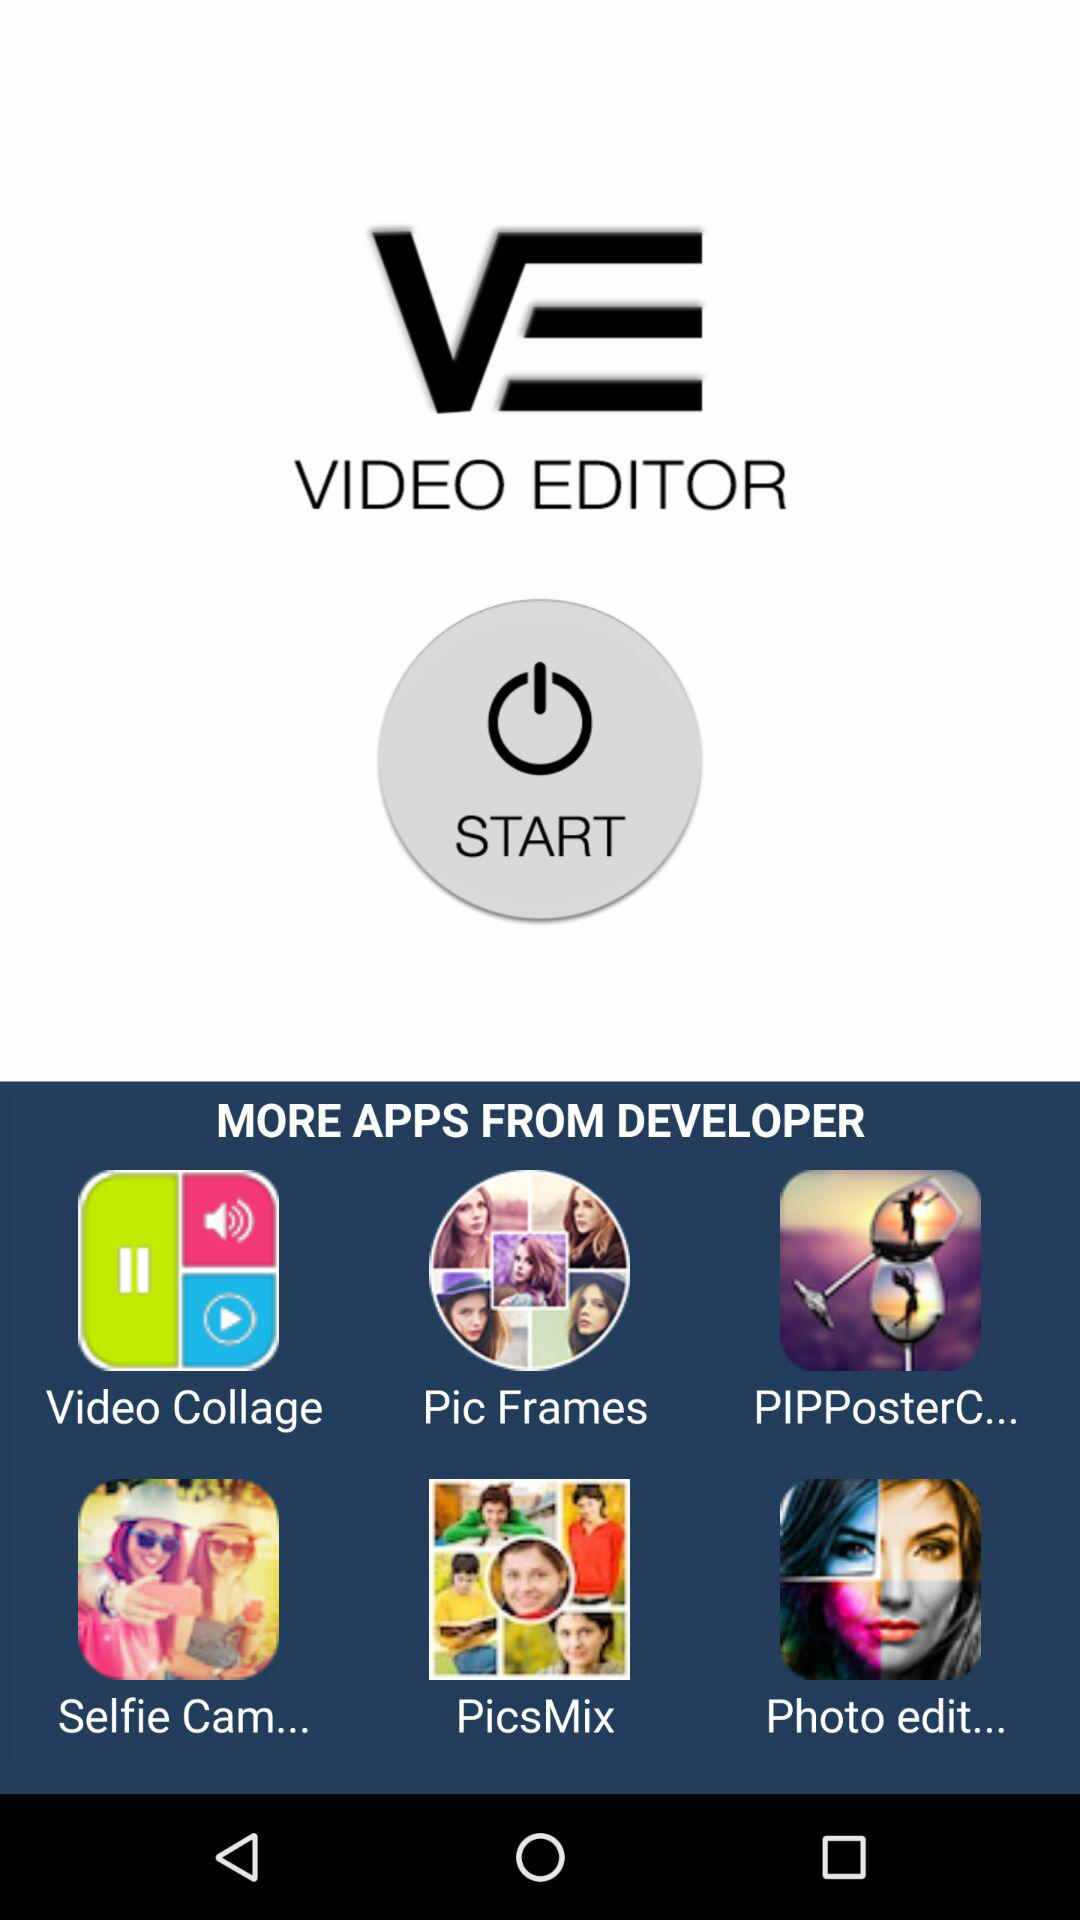What are the different applications available from the developer? Different available applications are "Video Collage", "Pic Frames", "PIPPosterC...", "Selfie Cam...", "PicsMix", and "Photo edit...". 